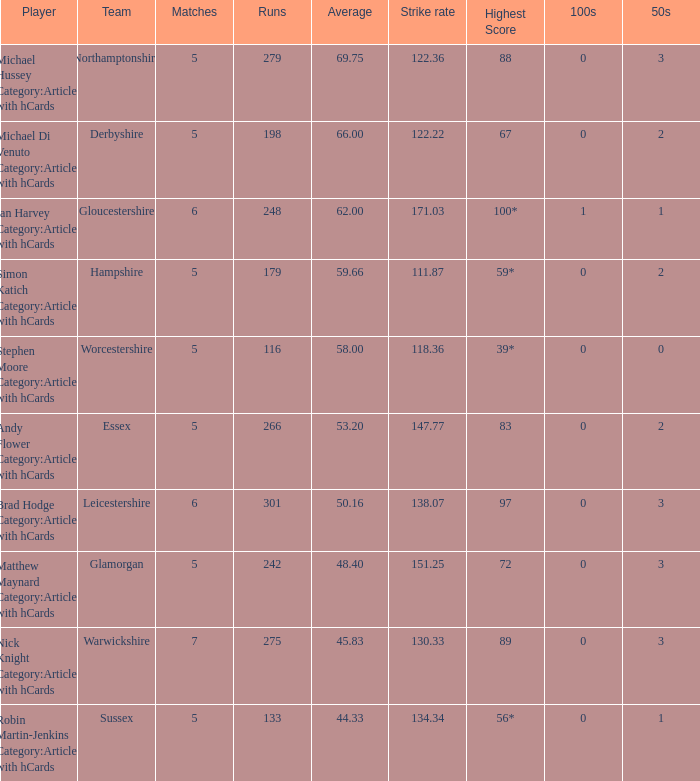What is the team Sussex' highest score? 56*. 